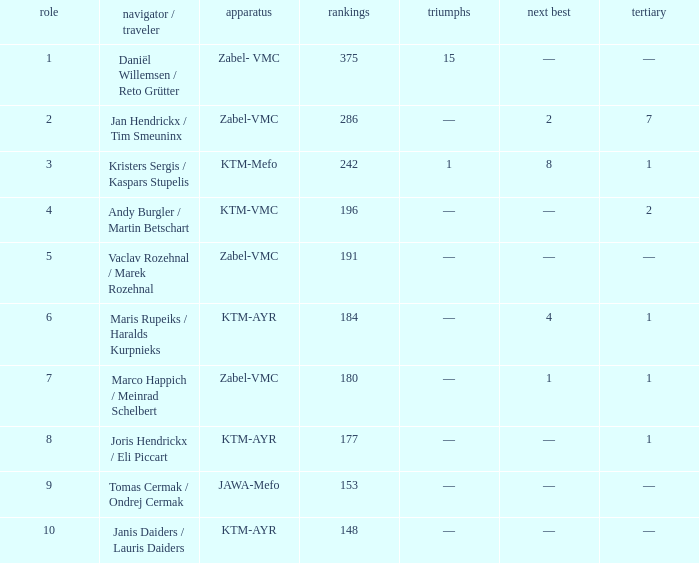Who was the driver/passengar when the position was smaller than 8, the third was 1, and there was 1 win? Kristers Sergis / Kaspars Stupelis. 